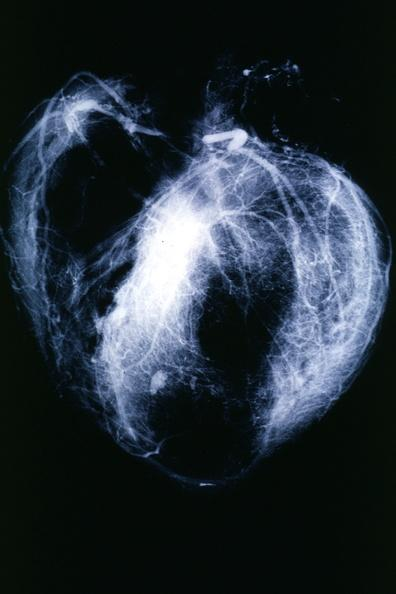s natural color present?
Answer the question using a single word or phrase. No 